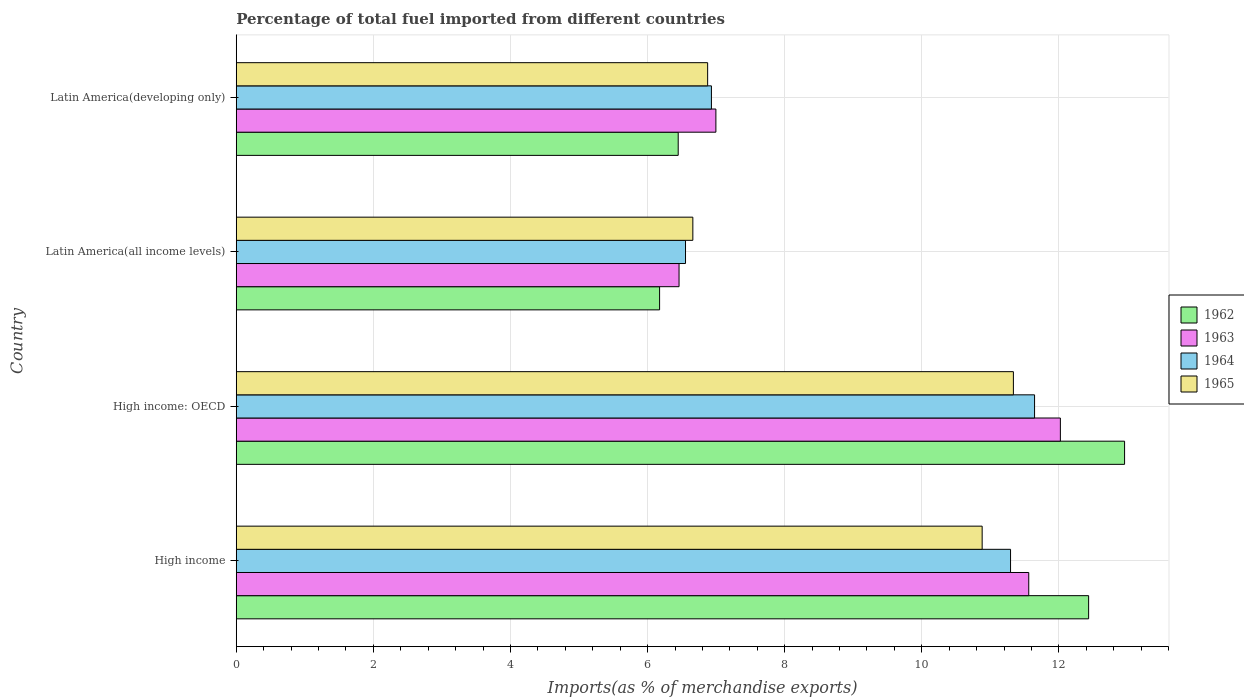How many groups of bars are there?
Make the answer very short. 4. Are the number of bars per tick equal to the number of legend labels?
Offer a terse response. Yes. Are the number of bars on each tick of the Y-axis equal?
Provide a succinct answer. Yes. How many bars are there on the 3rd tick from the top?
Make the answer very short. 4. How many bars are there on the 4th tick from the bottom?
Keep it short and to the point. 4. What is the label of the 4th group of bars from the top?
Ensure brevity in your answer.  High income. In how many cases, is the number of bars for a given country not equal to the number of legend labels?
Your answer should be very brief. 0. What is the percentage of imports to different countries in 1964 in High income?
Give a very brief answer. 11.29. Across all countries, what is the maximum percentage of imports to different countries in 1962?
Ensure brevity in your answer.  12.96. Across all countries, what is the minimum percentage of imports to different countries in 1963?
Give a very brief answer. 6.46. In which country was the percentage of imports to different countries in 1962 maximum?
Your response must be concise. High income: OECD. In which country was the percentage of imports to different countries in 1962 minimum?
Make the answer very short. Latin America(all income levels). What is the total percentage of imports to different countries in 1964 in the graph?
Make the answer very short. 36.42. What is the difference between the percentage of imports to different countries in 1965 in High income and that in Latin America(developing only)?
Your answer should be very brief. 4. What is the difference between the percentage of imports to different countries in 1965 in High income and the percentage of imports to different countries in 1964 in Latin America(developing only)?
Provide a short and direct response. 3.95. What is the average percentage of imports to different countries in 1964 per country?
Offer a terse response. 9.11. What is the difference between the percentage of imports to different countries in 1965 and percentage of imports to different countries in 1963 in High income: OECD?
Your response must be concise. -0.69. What is the ratio of the percentage of imports to different countries in 1962 in High income: OECD to that in Latin America(all income levels)?
Make the answer very short. 2.1. Is the difference between the percentage of imports to different countries in 1965 in High income and Latin America(all income levels) greater than the difference between the percentage of imports to different countries in 1963 in High income and Latin America(all income levels)?
Your answer should be very brief. No. What is the difference between the highest and the second highest percentage of imports to different countries in 1964?
Your answer should be compact. 0.35. What is the difference between the highest and the lowest percentage of imports to different countries in 1962?
Give a very brief answer. 6.78. Is the sum of the percentage of imports to different countries in 1965 in High income and High income: OECD greater than the maximum percentage of imports to different countries in 1962 across all countries?
Offer a very short reply. Yes. Is it the case that in every country, the sum of the percentage of imports to different countries in 1963 and percentage of imports to different countries in 1965 is greater than the sum of percentage of imports to different countries in 1964 and percentage of imports to different countries in 1962?
Provide a succinct answer. No. What does the 3rd bar from the top in High income represents?
Your response must be concise. 1963. What does the 4th bar from the bottom in High income represents?
Your answer should be compact. 1965. Is it the case that in every country, the sum of the percentage of imports to different countries in 1965 and percentage of imports to different countries in 1963 is greater than the percentage of imports to different countries in 1964?
Your response must be concise. Yes. How many bars are there?
Offer a terse response. 16. Are all the bars in the graph horizontal?
Offer a terse response. Yes. What is the difference between two consecutive major ticks on the X-axis?
Keep it short and to the point. 2. How many legend labels are there?
Ensure brevity in your answer.  4. What is the title of the graph?
Keep it short and to the point. Percentage of total fuel imported from different countries. Does "1971" appear as one of the legend labels in the graph?
Make the answer very short. No. What is the label or title of the X-axis?
Offer a terse response. Imports(as % of merchandise exports). What is the label or title of the Y-axis?
Your answer should be very brief. Country. What is the Imports(as % of merchandise exports) in 1962 in High income?
Give a very brief answer. 12.43. What is the Imports(as % of merchandise exports) of 1963 in High income?
Ensure brevity in your answer.  11.56. What is the Imports(as % of merchandise exports) of 1964 in High income?
Make the answer very short. 11.29. What is the Imports(as % of merchandise exports) of 1965 in High income?
Ensure brevity in your answer.  10.88. What is the Imports(as % of merchandise exports) of 1962 in High income: OECD?
Make the answer very short. 12.96. What is the Imports(as % of merchandise exports) in 1963 in High income: OECD?
Make the answer very short. 12.02. What is the Imports(as % of merchandise exports) of 1964 in High income: OECD?
Ensure brevity in your answer.  11.64. What is the Imports(as % of merchandise exports) in 1965 in High income: OECD?
Your answer should be very brief. 11.34. What is the Imports(as % of merchandise exports) in 1962 in Latin America(all income levels)?
Your response must be concise. 6.17. What is the Imports(as % of merchandise exports) in 1963 in Latin America(all income levels)?
Offer a very short reply. 6.46. What is the Imports(as % of merchandise exports) in 1964 in Latin America(all income levels)?
Give a very brief answer. 6.55. What is the Imports(as % of merchandise exports) of 1965 in Latin America(all income levels)?
Keep it short and to the point. 6.66. What is the Imports(as % of merchandise exports) of 1962 in Latin America(developing only)?
Provide a short and direct response. 6.45. What is the Imports(as % of merchandise exports) in 1963 in Latin America(developing only)?
Keep it short and to the point. 7. What is the Imports(as % of merchandise exports) in 1964 in Latin America(developing only)?
Your answer should be compact. 6.93. What is the Imports(as % of merchandise exports) in 1965 in Latin America(developing only)?
Offer a terse response. 6.88. Across all countries, what is the maximum Imports(as % of merchandise exports) of 1962?
Provide a short and direct response. 12.96. Across all countries, what is the maximum Imports(as % of merchandise exports) of 1963?
Ensure brevity in your answer.  12.02. Across all countries, what is the maximum Imports(as % of merchandise exports) in 1964?
Your answer should be very brief. 11.64. Across all countries, what is the maximum Imports(as % of merchandise exports) of 1965?
Ensure brevity in your answer.  11.34. Across all countries, what is the minimum Imports(as % of merchandise exports) in 1962?
Offer a very short reply. 6.17. Across all countries, what is the minimum Imports(as % of merchandise exports) of 1963?
Your response must be concise. 6.46. Across all countries, what is the minimum Imports(as % of merchandise exports) of 1964?
Keep it short and to the point. 6.55. Across all countries, what is the minimum Imports(as % of merchandise exports) in 1965?
Provide a short and direct response. 6.66. What is the total Imports(as % of merchandise exports) of 1962 in the graph?
Offer a very short reply. 38.01. What is the total Imports(as % of merchandise exports) in 1963 in the graph?
Make the answer very short. 37.04. What is the total Imports(as % of merchandise exports) of 1964 in the graph?
Your answer should be very brief. 36.42. What is the total Imports(as % of merchandise exports) of 1965 in the graph?
Your answer should be compact. 35.75. What is the difference between the Imports(as % of merchandise exports) in 1962 in High income and that in High income: OECD?
Your response must be concise. -0.52. What is the difference between the Imports(as % of merchandise exports) of 1963 in High income and that in High income: OECD?
Make the answer very short. -0.46. What is the difference between the Imports(as % of merchandise exports) in 1964 in High income and that in High income: OECD?
Ensure brevity in your answer.  -0.35. What is the difference between the Imports(as % of merchandise exports) in 1965 in High income and that in High income: OECD?
Provide a short and direct response. -0.46. What is the difference between the Imports(as % of merchandise exports) of 1962 in High income and that in Latin America(all income levels)?
Provide a succinct answer. 6.26. What is the difference between the Imports(as % of merchandise exports) of 1963 in High income and that in Latin America(all income levels)?
Offer a very short reply. 5.1. What is the difference between the Imports(as % of merchandise exports) of 1964 in High income and that in Latin America(all income levels)?
Give a very brief answer. 4.74. What is the difference between the Imports(as % of merchandise exports) of 1965 in High income and that in Latin America(all income levels)?
Make the answer very short. 4.22. What is the difference between the Imports(as % of merchandise exports) of 1962 in High income and that in Latin America(developing only)?
Your answer should be very brief. 5.99. What is the difference between the Imports(as % of merchandise exports) in 1963 in High income and that in Latin America(developing only)?
Provide a succinct answer. 4.56. What is the difference between the Imports(as % of merchandise exports) of 1964 in High income and that in Latin America(developing only)?
Provide a succinct answer. 4.36. What is the difference between the Imports(as % of merchandise exports) in 1965 in High income and that in Latin America(developing only)?
Give a very brief answer. 4. What is the difference between the Imports(as % of merchandise exports) of 1962 in High income: OECD and that in Latin America(all income levels)?
Give a very brief answer. 6.78. What is the difference between the Imports(as % of merchandise exports) in 1963 in High income: OECD and that in Latin America(all income levels)?
Offer a terse response. 5.56. What is the difference between the Imports(as % of merchandise exports) of 1964 in High income: OECD and that in Latin America(all income levels)?
Provide a succinct answer. 5.09. What is the difference between the Imports(as % of merchandise exports) in 1965 in High income: OECD and that in Latin America(all income levels)?
Make the answer very short. 4.68. What is the difference between the Imports(as % of merchandise exports) of 1962 in High income: OECD and that in Latin America(developing only)?
Your answer should be compact. 6.51. What is the difference between the Imports(as % of merchandise exports) of 1963 in High income: OECD and that in Latin America(developing only)?
Provide a short and direct response. 5.02. What is the difference between the Imports(as % of merchandise exports) in 1964 in High income: OECD and that in Latin America(developing only)?
Give a very brief answer. 4.71. What is the difference between the Imports(as % of merchandise exports) in 1965 in High income: OECD and that in Latin America(developing only)?
Your response must be concise. 4.46. What is the difference between the Imports(as % of merchandise exports) in 1962 in Latin America(all income levels) and that in Latin America(developing only)?
Offer a very short reply. -0.27. What is the difference between the Imports(as % of merchandise exports) of 1963 in Latin America(all income levels) and that in Latin America(developing only)?
Keep it short and to the point. -0.54. What is the difference between the Imports(as % of merchandise exports) of 1964 in Latin America(all income levels) and that in Latin America(developing only)?
Ensure brevity in your answer.  -0.38. What is the difference between the Imports(as % of merchandise exports) in 1965 in Latin America(all income levels) and that in Latin America(developing only)?
Make the answer very short. -0.22. What is the difference between the Imports(as % of merchandise exports) in 1962 in High income and the Imports(as % of merchandise exports) in 1963 in High income: OECD?
Ensure brevity in your answer.  0.41. What is the difference between the Imports(as % of merchandise exports) of 1962 in High income and the Imports(as % of merchandise exports) of 1964 in High income: OECD?
Your answer should be very brief. 0.79. What is the difference between the Imports(as % of merchandise exports) of 1962 in High income and the Imports(as % of merchandise exports) of 1965 in High income: OECD?
Provide a succinct answer. 1.1. What is the difference between the Imports(as % of merchandise exports) of 1963 in High income and the Imports(as % of merchandise exports) of 1964 in High income: OECD?
Provide a short and direct response. -0.09. What is the difference between the Imports(as % of merchandise exports) in 1963 in High income and the Imports(as % of merchandise exports) in 1965 in High income: OECD?
Make the answer very short. 0.22. What is the difference between the Imports(as % of merchandise exports) in 1964 in High income and the Imports(as % of merchandise exports) in 1965 in High income: OECD?
Offer a terse response. -0.04. What is the difference between the Imports(as % of merchandise exports) in 1962 in High income and the Imports(as % of merchandise exports) in 1963 in Latin America(all income levels)?
Give a very brief answer. 5.97. What is the difference between the Imports(as % of merchandise exports) of 1962 in High income and the Imports(as % of merchandise exports) of 1964 in Latin America(all income levels)?
Your answer should be compact. 5.88. What is the difference between the Imports(as % of merchandise exports) in 1962 in High income and the Imports(as % of merchandise exports) in 1965 in Latin America(all income levels)?
Your answer should be compact. 5.77. What is the difference between the Imports(as % of merchandise exports) in 1963 in High income and the Imports(as % of merchandise exports) in 1964 in Latin America(all income levels)?
Your answer should be compact. 5.01. What is the difference between the Imports(as % of merchandise exports) of 1963 in High income and the Imports(as % of merchandise exports) of 1965 in Latin America(all income levels)?
Ensure brevity in your answer.  4.9. What is the difference between the Imports(as % of merchandise exports) in 1964 in High income and the Imports(as % of merchandise exports) in 1965 in Latin America(all income levels)?
Provide a succinct answer. 4.63. What is the difference between the Imports(as % of merchandise exports) in 1962 in High income and the Imports(as % of merchandise exports) in 1963 in Latin America(developing only)?
Keep it short and to the point. 5.44. What is the difference between the Imports(as % of merchandise exports) of 1962 in High income and the Imports(as % of merchandise exports) of 1964 in Latin America(developing only)?
Your answer should be compact. 5.5. What is the difference between the Imports(as % of merchandise exports) in 1962 in High income and the Imports(as % of merchandise exports) in 1965 in Latin America(developing only)?
Ensure brevity in your answer.  5.56. What is the difference between the Imports(as % of merchandise exports) in 1963 in High income and the Imports(as % of merchandise exports) in 1964 in Latin America(developing only)?
Offer a terse response. 4.63. What is the difference between the Imports(as % of merchandise exports) of 1963 in High income and the Imports(as % of merchandise exports) of 1965 in Latin America(developing only)?
Offer a very short reply. 4.68. What is the difference between the Imports(as % of merchandise exports) of 1964 in High income and the Imports(as % of merchandise exports) of 1965 in Latin America(developing only)?
Provide a short and direct response. 4.42. What is the difference between the Imports(as % of merchandise exports) of 1962 in High income: OECD and the Imports(as % of merchandise exports) of 1963 in Latin America(all income levels)?
Your answer should be compact. 6.5. What is the difference between the Imports(as % of merchandise exports) of 1962 in High income: OECD and the Imports(as % of merchandise exports) of 1964 in Latin America(all income levels)?
Your answer should be compact. 6.4. What is the difference between the Imports(as % of merchandise exports) in 1962 in High income: OECD and the Imports(as % of merchandise exports) in 1965 in Latin America(all income levels)?
Ensure brevity in your answer.  6.3. What is the difference between the Imports(as % of merchandise exports) of 1963 in High income: OECD and the Imports(as % of merchandise exports) of 1964 in Latin America(all income levels)?
Offer a very short reply. 5.47. What is the difference between the Imports(as % of merchandise exports) of 1963 in High income: OECD and the Imports(as % of merchandise exports) of 1965 in Latin America(all income levels)?
Your answer should be very brief. 5.36. What is the difference between the Imports(as % of merchandise exports) of 1964 in High income: OECD and the Imports(as % of merchandise exports) of 1965 in Latin America(all income levels)?
Offer a very short reply. 4.98. What is the difference between the Imports(as % of merchandise exports) of 1962 in High income: OECD and the Imports(as % of merchandise exports) of 1963 in Latin America(developing only)?
Your answer should be very brief. 5.96. What is the difference between the Imports(as % of merchandise exports) of 1962 in High income: OECD and the Imports(as % of merchandise exports) of 1964 in Latin America(developing only)?
Offer a terse response. 6.03. What is the difference between the Imports(as % of merchandise exports) of 1962 in High income: OECD and the Imports(as % of merchandise exports) of 1965 in Latin America(developing only)?
Provide a succinct answer. 6.08. What is the difference between the Imports(as % of merchandise exports) in 1963 in High income: OECD and the Imports(as % of merchandise exports) in 1964 in Latin America(developing only)?
Offer a terse response. 5.09. What is the difference between the Imports(as % of merchandise exports) in 1963 in High income: OECD and the Imports(as % of merchandise exports) in 1965 in Latin America(developing only)?
Offer a very short reply. 5.15. What is the difference between the Imports(as % of merchandise exports) of 1964 in High income: OECD and the Imports(as % of merchandise exports) of 1965 in Latin America(developing only)?
Offer a terse response. 4.77. What is the difference between the Imports(as % of merchandise exports) in 1962 in Latin America(all income levels) and the Imports(as % of merchandise exports) in 1963 in Latin America(developing only)?
Give a very brief answer. -0.82. What is the difference between the Imports(as % of merchandise exports) of 1962 in Latin America(all income levels) and the Imports(as % of merchandise exports) of 1964 in Latin America(developing only)?
Offer a terse response. -0.76. What is the difference between the Imports(as % of merchandise exports) in 1962 in Latin America(all income levels) and the Imports(as % of merchandise exports) in 1965 in Latin America(developing only)?
Provide a succinct answer. -0.7. What is the difference between the Imports(as % of merchandise exports) in 1963 in Latin America(all income levels) and the Imports(as % of merchandise exports) in 1964 in Latin America(developing only)?
Your answer should be compact. -0.47. What is the difference between the Imports(as % of merchandise exports) in 1963 in Latin America(all income levels) and the Imports(as % of merchandise exports) in 1965 in Latin America(developing only)?
Your response must be concise. -0.42. What is the difference between the Imports(as % of merchandise exports) of 1964 in Latin America(all income levels) and the Imports(as % of merchandise exports) of 1965 in Latin America(developing only)?
Make the answer very short. -0.32. What is the average Imports(as % of merchandise exports) in 1962 per country?
Your answer should be compact. 9.5. What is the average Imports(as % of merchandise exports) of 1963 per country?
Keep it short and to the point. 9.26. What is the average Imports(as % of merchandise exports) in 1964 per country?
Your answer should be very brief. 9.11. What is the average Imports(as % of merchandise exports) of 1965 per country?
Your response must be concise. 8.94. What is the difference between the Imports(as % of merchandise exports) of 1962 and Imports(as % of merchandise exports) of 1963 in High income?
Offer a very short reply. 0.87. What is the difference between the Imports(as % of merchandise exports) in 1962 and Imports(as % of merchandise exports) in 1964 in High income?
Ensure brevity in your answer.  1.14. What is the difference between the Imports(as % of merchandise exports) in 1962 and Imports(as % of merchandise exports) in 1965 in High income?
Your response must be concise. 1.55. What is the difference between the Imports(as % of merchandise exports) of 1963 and Imports(as % of merchandise exports) of 1964 in High income?
Your answer should be compact. 0.27. What is the difference between the Imports(as % of merchandise exports) in 1963 and Imports(as % of merchandise exports) in 1965 in High income?
Your answer should be compact. 0.68. What is the difference between the Imports(as % of merchandise exports) in 1964 and Imports(as % of merchandise exports) in 1965 in High income?
Your response must be concise. 0.41. What is the difference between the Imports(as % of merchandise exports) of 1962 and Imports(as % of merchandise exports) of 1963 in High income: OECD?
Your answer should be compact. 0.94. What is the difference between the Imports(as % of merchandise exports) in 1962 and Imports(as % of merchandise exports) in 1964 in High income: OECD?
Your response must be concise. 1.31. What is the difference between the Imports(as % of merchandise exports) of 1962 and Imports(as % of merchandise exports) of 1965 in High income: OECD?
Provide a succinct answer. 1.62. What is the difference between the Imports(as % of merchandise exports) of 1963 and Imports(as % of merchandise exports) of 1964 in High income: OECD?
Your answer should be compact. 0.38. What is the difference between the Imports(as % of merchandise exports) of 1963 and Imports(as % of merchandise exports) of 1965 in High income: OECD?
Offer a terse response. 0.69. What is the difference between the Imports(as % of merchandise exports) of 1964 and Imports(as % of merchandise exports) of 1965 in High income: OECD?
Make the answer very short. 0.31. What is the difference between the Imports(as % of merchandise exports) of 1962 and Imports(as % of merchandise exports) of 1963 in Latin America(all income levels)?
Offer a very short reply. -0.28. What is the difference between the Imports(as % of merchandise exports) in 1962 and Imports(as % of merchandise exports) in 1964 in Latin America(all income levels)?
Keep it short and to the point. -0.38. What is the difference between the Imports(as % of merchandise exports) in 1962 and Imports(as % of merchandise exports) in 1965 in Latin America(all income levels)?
Your answer should be very brief. -0.48. What is the difference between the Imports(as % of merchandise exports) of 1963 and Imports(as % of merchandise exports) of 1964 in Latin America(all income levels)?
Your response must be concise. -0.09. What is the difference between the Imports(as % of merchandise exports) in 1963 and Imports(as % of merchandise exports) in 1965 in Latin America(all income levels)?
Provide a short and direct response. -0.2. What is the difference between the Imports(as % of merchandise exports) in 1964 and Imports(as % of merchandise exports) in 1965 in Latin America(all income levels)?
Your answer should be very brief. -0.11. What is the difference between the Imports(as % of merchandise exports) of 1962 and Imports(as % of merchandise exports) of 1963 in Latin America(developing only)?
Make the answer very short. -0.55. What is the difference between the Imports(as % of merchandise exports) in 1962 and Imports(as % of merchandise exports) in 1964 in Latin America(developing only)?
Provide a short and direct response. -0.48. What is the difference between the Imports(as % of merchandise exports) in 1962 and Imports(as % of merchandise exports) in 1965 in Latin America(developing only)?
Your response must be concise. -0.43. What is the difference between the Imports(as % of merchandise exports) in 1963 and Imports(as % of merchandise exports) in 1964 in Latin America(developing only)?
Your answer should be compact. 0.07. What is the difference between the Imports(as % of merchandise exports) in 1963 and Imports(as % of merchandise exports) in 1965 in Latin America(developing only)?
Provide a succinct answer. 0.12. What is the difference between the Imports(as % of merchandise exports) in 1964 and Imports(as % of merchandise exports) in 1965 in Latin America(developing only)?
Provide a succinct answer. 0.06. What is the ratio of the Imports(as % of merchandise exports) of 1962 in High income to that in High income: OECD?
Give a very brief answer. 0.96. What is the ratio of the Imports(as % of merchandise exports) of 1963 in High income to that in High income: OECD?
Offer a terse response. 0.96. What is the ratio of the Imports(as % of merchandise exports) of 1964 in High income to that in High income: OECD?
Your answer should be compact. 0.97. What is the ratio of the Imports(as % of merchandise exports) of 1965 in High income to that in High income: OECD?
Keep it short and to the point. 0.96. What is the ratio of the Imports(as % of merchandise exports) in 1962 in High income to that in Latin America(all income levels)?
Ensure brevity in your answer.  2.01. What is the ratio of the Imports(as % of merchandise exports) of 1963 in High income to that in Latin America(all income levels)?
Make the answer very short. 1.79. What is the ratio of the Imports(as % of merchandise exports) of 1964 in High income to that in Latin America(all income levels)?
Your answer should be compact. 1.72. What is the ratio of the Imports(as % of merchandise exports) of 1965 in High income to that in Latin America(all income levels)?
Offer a terse response. 1.63. What is the ratio of the Imports(as % of merchandise exports) in 1962 in High income to that in Latin America(developing only)?
Your answer should be compact. 1.93. What is the ratio of the Imports(as % of merchandise exports) of 1963 in High income to that in Latin America(developing only)?
Your response must be concise. 1.65. What is the ratio of the Imports(as % of merchandise exports) in 1964 in High income to that in Latin America(developing only)?
Your response must be concise. 1.63. What is the ratio of the Imports(as % of merchandise exports) of 1965 in High income to that in Latin America(developing only)?
Provide a succinct answer. 1.58. What is the ratio of the Imports(as % of merchandise exports) in 1962 in High income: OECD to that in Latin America(all income levels)?
Your answer should be compact. 2.1. What is the ratio of the Imports(as % of merchandise exports) in 1963 in High income: OECD to that in Latin America(all income levels)?
Provide a short and direct response. 1.86. What is the ratio of the Imports(as % of merchandise exports) in 1964 in High income: OECD to that in Latin America(all income levels)?
Your response must be concise. 1.78. What is the ratio of the Imports(as % of merchandise exports) of 1965 in High income: OECD to that in Latin America(all income levels)?
Provide a short and direct response. 1.7. What is the ratio of the Imports(as % of merchandise exports) of 1962 in High income: OECD to that in Latin America(developing only)?
Give a very brief answer. 2.01. What is the ratio of the Imports(as % of merchandise exports) of 1963 in High income: OECD to that in Latin America(developing only)?
Keep it short and to the point. 1.72. What is the ratio of the Imports(as % of merchandise exports) in 1964 in High income: OECD to that in Latin America(developing only)?
Your answer should be very brief. 1.68. What is the ratio of the Imports(as % of merchandise exports) of 1965 in High income: OECD to that in Latin America(developing only)?
Make the answer very short. 1.65. What is the ratio of the Imports(as % of merchandise exports) in 1962 in Latin America(all income levels) to that in Latin America(developing only)?
Make the answer very short. 0.96. What is the ratio of the Imports(as % of merchandise exports) in 1963 in Latin America(all income levels) to that in Latin America(developing only)?
Give a very brief answer. 0.92. What is the ratio of the Imports(as % of merchandise exports) in 1964 in Latin America(all income levels) to that in Latin America(developing only)?
Give a very brief answer. 0.95. What is the ratio of the Imports(as % of merchandise exports) in 1965 in Latin America(all income levels) to that in Latin America(developing only)?
Offer a terse response. 0.97. What is the difference between the highest and the second highest Imports(as % of merchandise exports) in 1962?
Ensure brevity in your answer.  0.52. What is the difference between the highest and the second highest Imports(as % of merchandise exports) in 1963?
Your answer should be compact. 0.46. What is the difference between the highest and the second highest Imports(as % of merchandise exports) of 1964?
Your answer should be compact. 0.35. What is the difference between the highest and the second highest Imports(as % of merchandise exports) of 1965?
Provide a succinct answer. 0.46. What is the difference between the highest and the lowest Imports(as % of merchandise exports) in 1962?
Give a very brief answer. 6.78. What is the difference between the highest and the lowest Imports(as % of merchandise exports) in 1963?
Your response must be concise. 5.56. What is the difference between the highest and the lowest Imports(as % of merchandise exports) of 1964?
Give a very brief answer. 5.09. What is the difference between the highest and the lowest Imports(as % of merchandise exports) of 1965?
Provide a short and direct response. 4.68. 